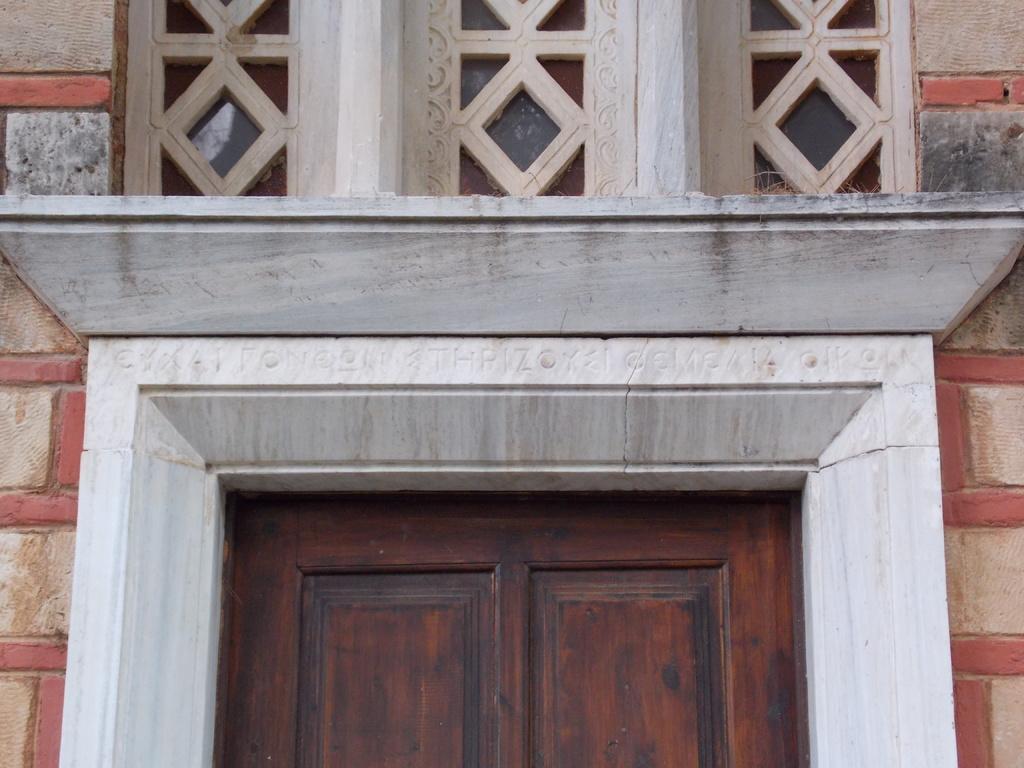Could you give a brief overview of what you see in this image? In the center of the image there is a door. There is a wall. 